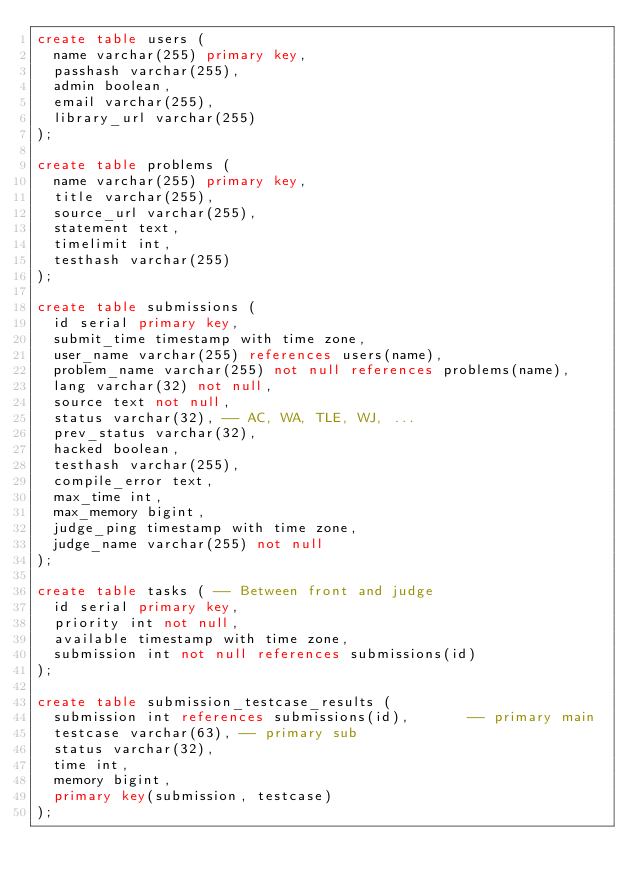Convert code to text. <code><loc_0><loc_0><loc_500><loc_500><_SQL_>create table users (  
  name varchar(255) primary key,
  passhash varchar(255),
  admin boolean,
  email varchar(255),
  library_url varchar(255)
);

create table problems (
  name varchar(255) primary key,
  title varchar(255),
  source_url varchar(255),
  statement text,
  timelimit int,
  testhash varchar(255)
);

create table submissions (
  id serial primary key,
  submit_time timestamp with time zone,
  user_name varchar(255) references users(name),
  problem_name varchar(255) not null references problems(name),
  lang varchar(32) not null,
  source text not null,
  status varchar(32), -- AC, WA, TLE, WJ, ...
  prev_status varchar(32),
  hacked boolean,
  testhash varchar(255),
  compile_error text,
  max_time int,
  max_memory bigint,
  judge_ping timestamp with time zone,
  judge_name varchar(255) not null
);

create table tasks ( -- Between front and judge
  id serial primary key,
  priority int not null,
  available timestamp with time zone,
  submission int not null references submissions(id)
);

create table submission_testcase_results (
  submission int references submissions(id),       -- primary main
  testcase varchar(63), -- primary sub
  status varchar(32),
  time int,
  memory bigint,
  primary key(submission, testcase)
);
</code> 